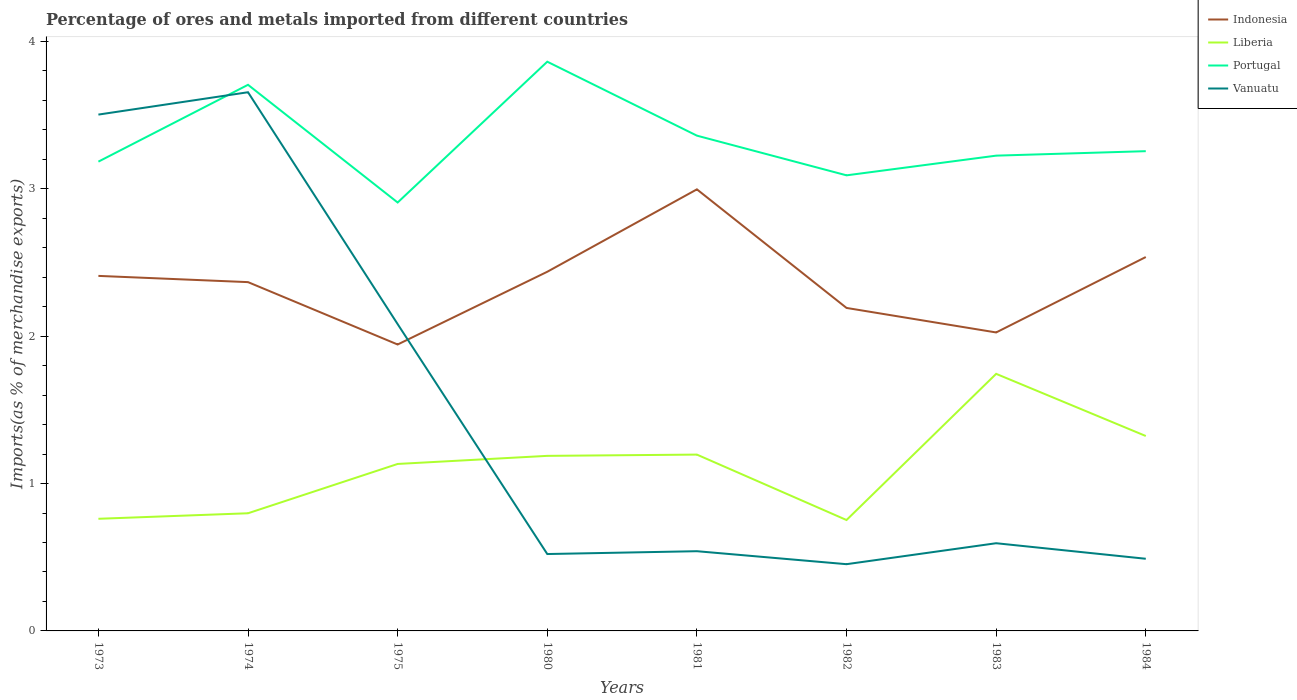How many different coloured lines are there?
Provide a short and direct response. 4. Is the number of lines equal to the number of legend labels?
Make the answer very short. Yes. Across all years, what is the maximum percentage of imports to different countries in Vanuatu?
Your answer should be compact. 0.45. What is the total percentage of imports to different countries in Indonesia in the graph?
Give a very brief answer. -0.08. What is the difference between the highest and the second highest percentage of imports to different countries in Vanuatu?
Make the answer very short. 3.2. What is the difference between the highest and the lowest percentage of imports to different countries in Liberia?
Your response must be concise. 5. Is the percentage of imports to different countries in Liberia strictly greater than the percentage of imports to different countries in Portugal over the years?
Ensure brevity in your answer.  Yes. How many years are there in the graph?
Offer a very short reply. 8. What is the difference between two consecutive major ticks on the Y-axis?
Make the answer very short. 1. Does the graph contain grids?
Your answer should be very brief. No. How are the legend labels stacked?
Your answer should be compact. Vertical. What is the title of the graph?
Your response must be concise. Percentage of ores and metals imported from different countries. What is the label or title of the X-axis?
Your answer should be very brief. Years. What is the label or title of the Y-axis?
Provide a succinct answer. Imports(as % of merchandise exports). What is the Imports(as % of merchandise exports) in Indonesia in 1973?
Provide a succinct answer. 2.41. What is the Imports(as % of merchandise exports) of Liberia in 1973?
Your answer should be compact. 0.76. What is the Imports(as % of merchandise exports) in Portugal in 1973?
Offer a terse response. 3.18. What is the Imports(as % of merchandise exports) of Vanuatu in 1973?
Offer a very short reply. 3.5. What is the Imports(as % of merchandise exports) of Indonesia in 1974?
Make the answer very short. 2.37. What is the Imports(as % of merchandise exports) of Liberia in 1974?
Provide a succinct answer. 0.8. What is the Imports(as % of merchandise exports) of Portugal in 1974?
Offer a terse response. 3.71. What is the Imports(as % of merchandise exports) in Vanuatu in 1974?
Provide a short and direct response. 3.66. What is the Imports(as % of merchandise exports) of Indonesia in 1975?
Your answer should be very brief. 1.94. What is the Imports(as % of merchandise exports) in Liberia in 1975?
Give a very brief answer. 1.13. What is the Imports(as % of merchandise exports) in Portugal in 1975?
Give a very brief answer. 2.91. What is the Imports(as % of merchandise exports) of Vanuatu in 1975?
Keep it short and to the point. 2.08. What is the Imports(as % of merchandise exports) in Indonesia in 1980?
Offer a very short reply. 2.44. What is the Imports(as % of merchandise exports) in Liberia in 1980?
Your answer should be compact. 1.19. What is the Imports(as % of merchandise exports) of Portugal in 1980?
Offer a very short reply. 3.86. What is the Imports(as % of merchandise exports) of Vanuatu in 1980?
Give a very brief answer. 0.52. What is the Imports(as % of merchandise exports) in Indonesia in 1981?
Your response must be concise. 3. What is the Imports(as % of merchandise exports) of Liberia in 1981?
Offer a very short reply. 1.2. What is the Imports(as % of merchandise exports) of Portugal in 1981?
Your answer should be compact. 3.36. What is the Imports(as % of merchandise exports) in Vanuatu in 1981?
Provide a succinct answer. 0.54. What is the Imports(as % of merchandise exports) of Indonesia in 1982?
Your response must be concise. 2.19. What is the Imports(as % of merchandise exports) in Liberia in 1982?
Your answer should be very brief. 0.75. What is the Imports(as % of merchandise exports) of Portugal in 1982?
Your answer should be very brief. 3.09. What is the Imports(as % of merchandise exports) in Vanuatu in 1982?
Ensure brevity in your answer.  0.45. What is the Imports(as % of merchandise exports) of Indonesia in 1983?
Make the answer very short. 2.03. What is the Imports(as % of merchandise exports) of Liberia in 1983?
Offer a very short reply. 1.74. What is the Imports(as % of merchandise exports) of Portugal in 1983?
Your response must be concise. 3.23. What is the Imports(as % of merchandise exports) of Vanuatu in 1983?
Ensure brevity in your answer.  0.6. What is the Imports(as % of merchandise exports) in Indonesia in 1984?
Ensure brevity in your answer.  2.54. What is the Imports(as % of merchandise exports) of Liberia in 1984?
Give a very brief answer. 1.32. What is the Imports(as % of merchandise exports) in Portugal in 1984?
Offer a terse response. 3.26. What is the Imports(as % of merchandise exports) of Vanuatu in 1984?
Your answer should be very brief. 0.49. Across all years, what is the maximum Imports(as % of merchandise exports) in Indonesia?
Keep it short and to the point. 3. Across all years, what is the maximum Imports(as % of merchandise exports) of Liberia?
Make the answer very short. 1.74. Across all years, what is the maximum Imports(as % of merchandise exports) of Portugal?
Give a very brief answer. 3.86. Across all years, what is the maximum Imports(as % of merchandise exports) of Vanuatu?
Keep it short and to the point. 3.66. Across all years, what is the minimum Imports(as % of merchandise exports) of Indonesia?
Your response must be concise. 1.94. Across all years, what is the minimum Imports(as % of merchandise exports) in Liberia?
Your response must be concise. 0.75. Across all years, what is the minimum Imports(as % of merchandise exports) of Portugal?
Your answer should be compact. 2.91. Across all years, what is the minimum Imports(as % of merchandise exports) in Vanuatu?
Make the answer very short. 0.45. What is the total Imports(as % of merchandise exports) in Indonesia in the graph?
Offer a terse response. 18.91. What is the total Imports(as % of merchandise exports) of Liberia in the graph?
Your answer should be compact. 8.9. What is the total Imports(as % of merchandise exports) of Portugal in the graph?
Provide a succinct answer. 26.6. What is the total Imports(as % of merchandise exports) in Vanuatu in the graph?
Your answer should be very brief. 11.84. What is the difference between the Imports(as % of merchandise exports) in Indonesia in 1973 and that in 1974?
Your response must be concise. 0.04. What is the difference between the Imports(as % of merchandise exports) in Liberia in 1973 and that in 1974?
Provide a short and direct response. -0.04. What is the difference between the Imports(as % of merchandise exports) of Portugal in 1973 and that in 1974?
Your answer should be compact. -0.52. What is the difference between the Imports(as % of merchandise exports) in Vanuatu in 1973 and that in 1974?
Your answer should be compact. -0.15. What is the difference between the Imports(as % of merchandise exports) in Indonesia in 1973 and that in 1975?
Offer a terse response. 0.47. What is the difference between the Imports(as % of merchandise exports) in Liberia in 1973 and that in 1975?
Your response must be concise. -0.37. What is the difference between the Imports(as % of merchandise exports) in Portugal in 1973 and that in 1975?
Your answer should be very brief. 0.28. What is the difference between the Imports(as % of merchandise exports) of Vanuatu in 1973 and that in 1975?
Offer a terse response. 1.42. What is the difference between the Imports(as % of merchandise exports) in Indonesia in 1973 and that in 1980?
Provide a short and direct response. -0.03. What is the difference between the Imports(as % of merchandise exports) of Liberia in 1973 and that in 1980?
Offer a terse response. -0.43. What is the difference between the Imports(as % of merchandise exports) in Portugal in 1973 and that in 1980?
Your answer should be very brief. -0.68. What is the difference between the Imports(as % of merchandise exports) of Vanuatu in 1973 and that in 1980?
Offer a very short reply. 2.98. What is the difference between the Imports(as % of merchandise exports) of Indonesia in 1973 and that in 1981?
Provide a succinct answer. -0.59. What is the difference between the Imports(as % of merchandise exports) of Liberia in 1973 and that in 1981?
Provide a succinct answer. -0.44. What is the difference between the Imports(as % of merchandise exports) of Portugal in 1973 and that in 1981?
Offer a very short reply. -0.18. What is the difference between the Imports(as % of merchandise exports) of Vanuatu in 1973 and that in 1981?
Offer a very short reply. 2.96. What is the difference between the Imports(as % of merchandise exports) of Indonesia in 1973 and that in 1982?
Your answer should be compact. 0.22. What is the difference between the Imports(as % of merchandise exports) of Liberia in 1973 and that in 1982?
Your response must be concise. 0.01. What is the difference between the Imports(as % of merchandise exports) in Portugal in 1973 and that in 1982?
Provide a succinct answer. 0.09. What is the difference between the Imports(as % of merchandise exports) of Vanuatu in 1973 and that in 1982?
Your answer should be compact. 3.05. What is the difference between the Imports(as % of merchandise exports) in Indonesia in 1973 and that in 1983?
Your answer should be very brief. 0.38. What is the difference between the Imports(as % of merchandise exports) in Liberia in 1973 and that in 1983?
Give a very brief answer. -0.98. What is the difference between the Imports(as % of merchandise exports) of Portugal in 1973 and that in 1983?
Ensure brevity in your answer.  -0.04. What is the difference between the Imports(as % of merchandise exports) in Vanuatu in 1973 and that in 1983?
Make the answer very short. 2.91. What is the difference between the Imports(as % of merchandise exports) in Indonesia in 1973 and that in 1984?
Provide a succinct answer. -0.13. What is the difference between the Imports(as % of merchandise exports) of Liberia in 1973 and that in 1984?
Give a very brief answer. -0.56. What is the difference between the Imports(as % of merchandise exports) in Portugal in 1973 and that in 1984?
Your answer should be very brief. -0.07. What is the difference between the Imports(as % of merchandise exports) in Vanuatu in 1973 and that in 1984?
Your answer should be very brief. 3.01. What is the difference between the Imports(as % of merchandise exports) in Indonesia in 1974 and that in 1975?
Your answer should be compact. 0.42. What is the difference between the Imports(as % of merchandise exports) of Liberia in 1974 and that in 1975?
Offer a very short reply. -0.33. What is the difference between the Imports(as % of merchandise exports) of Portugal in 1974 and that in 1975?
Your answer should be very brief. 0.8. What is the difference between the Imports(as % of merchandise exports) in Vanuatu in 1974 and that in 1975?
Provide a short and direct response. 1.57. What is the difference between the Imports(as % of merchandise exports) of Indonesia in 1974 and that in 1980?
Provide a succinct answer. -0.07. What is the difference between the Imports(as % of merchandise exports) of Liberia in 1974 and that in 1980?
Make the answer very short. -0.39. What is the difference between the Imports(as % of merchandise exports) of Portugal in 1974 and that in 1980?
Your answer should be very brief. -0.16. What is the difference between the Imports(as % of merchandise exports) in Vanuatu in 1974 and that in 1980?
Keep it short and to the point. 3.13. What is the difference between the Imports(as % of merchandise exports) of Indonesia in 1974 and that in 1981?
Provide a short and direct response. -0.63. What is the difference between the Imports(as % of merchandise exports) of Liberia in 1974 and that in 1981?
Your answer should be compact. -0.4. What is the difference between the Imports(as % of merchandise exports) in Portugal in 1974 and that in 1981?
Offer a terse response. 0.34. What is the difference between the Imports(as % of merchandise exports) of Vanuatu in 1974 and that in 1981?
Keep it short and to the point. 3.11. What is the difference between the Imports(as % of merchandise exports) in Indonesia in 1974 and that in 1982?
Ensure brevity in your answer.  0.18. What is the difference between the Imports(as % of merchandise exports) of Liberia in 1974 and that in 1982?
Provide a short and direct response. 0.05. What is the difference between the Imports(as % of merchandise exports) in Portugal in 1974 and that in 1982?
Provide a succinct answer. 0.61. What is the difference between the Imports(as % of merchandise exports) of Vanuatu in 1974 and that in 1982?
Make the answer very short. 3.2. What is the difference between the Imports(as % of merchandise exports) of Indonesia in 1974 and that in 1983?
Your answer should be compact. 0.34. What is the difference between the Imports(as % of merchandise exports) in Liberia in 1974 and that in 1983?
Offer a very short reply. -0.95. What is the difference between the Imports(as % of merchandise exports) in Portugal in 1974 and that in 1983?
Give a very brief answer. 0.48. What is the difference between the Imports(as % of merchandise exports) in Vanuatu in 1974 and that in 1983?
Offer a very short reply. 3.06. What is the difference between the Imports(as % of merchandise exports) in Indonesia in 1974 and that in 1984?
Make the answer very short. -0.17. What is the difference between the Imports(as % of merchandise exports) in Liberia in 1974 and that in 1984?
Provide a short and direct response. -0.52. What is the difference between the Imports(as % of merchandise exports) of Portugal in 1974 and that in 1984?
Give a very brief answer. 0.45. What is the difference between the Imports(as % of merchandise exports) in Vanuatu in 1974 and that in 1984?
Your response must be concise. 3.17. What is the difference between the Imports(as % of merchandise exports) in Indonesia in 1975 and that in 1980?
Your answer should be compact. -0.49. What is the difference between the Imports(as % of merchandise exports) of Liberia in 1975 and that in 1980?
Your answer should be very brief. -0.05. What is the difference between the Imports(as % of merchandise exports) in Portugal in 1975 and that in 1980?
Provide a short and direct response. -0.96. What is the difference between the Imports(as % of merchandise exports) of Vanuatu in 1975 and that in 1980?
Keep it short and to the point. 1.56. What is the difference between the Imports(as % of merchandise exports) of Indonesia in 1975 and that in 1981?
Your answer should be compact. -1.05. What is the difference between the Imports(as % of merchandise exports) of Liberia in 1975 and that in 1981?
Keep it short and to the point. -0.06. What is the difference between the Imports(as % of merchandise exports) of Portugal in 1975 and that in 1981?
Provide a short and direct response. -0.45. What is the difference between the Imports(as % of merchandise exports) of Vanuatu in 1975 and that in 1981?
Keep it short and to the point. 1.54. What is the difference between the Imports(as % of merchandise exports) of Indonesia in 1975 and that in 1982?
Provide a short and direct response. -0.25. What is the difference between the Imports(as % of merchandise exports) of Liberia in 1975 and that in 1982?
Give a very brief answer. 0.38. What is the difference between the Imports(as % of merchandise exports) of Portugal in 1975 and that in 1982?
Make the answer very short. -0.18. What is the difference between the Imports(as % of merchandise exports) of Vanuatu in 1975 and that in 1982?
Provide a succinct answer. 1.63. What is the difference between the Imports(as % of merchandise exports) in Indonesia in 1975 and that in 1983?
Provide a short and direct response. -0.08. What is the difference between the Imports(as % of merchandise exports) in Liberia in 1975 and that in 1983?
Provide a short and direct response. -0.61. What is the difference between the Imports(as % of merchandise exports) in Portugal in 1975 and that in 1983?
Keep it short and to the point. -0.32. What is the difference between the Imports(as % of merchandise exports) in Vanuatu in 1975 and that in 1983?
Your answer should be very brief. 1.49. What is the difference between the Imports(as % of merchandise exports) in Indonesia in 1975 and that in 1984?
Your answer should be very brief. -0.59. What is the difference between the Imports(as % of merchandise exports) in Liberia in 1975 and that in 1984?
Make the answer very short. -0.19. What is the difference between the Imports(as % of merchandise exports) in Portugal in 1975 and that in 1984?
Provide a short and direct response. -0.35. What is the difference between the Imports(as % of merchandise exports) of Vanuatu in 1975 and that in 1984?
Your answer should be compact. 1.59. What is the difference between the Imports(as % of merchandise exports) in Indonesia in 1980 and that in 1981?
Make the answer very short. -0.56. What is the difference between the Imports(as % of merchandise exports) of Liberia in 1980 and that in 1981?
Your answer should be very brief. -0.01. What is the difference between the Imports(as % of merchandise exports) in Portugal in 1980 and that in 1981?
Provide a succinct answer. 0.5. What is the difference between the Imports(as % of merchandise exports) in Vanuatu in 1980 and that in 1981?
Your answer should be compact. -0.02. What is the difference between the Imports(as % of merchandise exports) in Indonesia in 1980 and that in 1982?
Provide a short and direct response. 0.25. What is the difference between the Imports(as % of merchandise exports) of Liberia in 1980 and that in 1982?
Provide a short and direct response. 0.44. What is the difference between the Imports(as % of merchandise exports) in Portugal in 1980 and that in 1982?
Your answer should be very brief. 0.77. What is the difference between the Imports(as % of merchandise exports) in Vanuatu in 1980 and that in 1982?
Provide a short and direct response. 0.07. What is the difference between the Imports(as % of merchandise exports) of Indonesia in 1980 and that in 1983?
Your response must be concise. 0.41. What is the difference between the Imports(as % of merchandise exports) in Liberia in 1980 and that in 1983?
Your answer should be compact. -0.56. What is the difference between the Imports(as % of merchandise exports) of Portugal in 1980 and that in 1983?
Your answer should be very brief. 0.64. What is the difference between the Imports(as % of merchandise exports) in Vanuatu in 1980 and that in 1983?
Your answer should be compact. -0.07. What is the difference between the Imports(as % of merchandise exports) of Indonesia in 1980 and that in 1984?
Ensure brevity in your answer.  -0.1. What is the difference between the Imports(as % of merchandise exports) in Liberia in 1980 and that in 1984?
Ensure brevity in your answer.  -0.13. What is the difference between the Imports(as % of merchandise exports) in Portugal in 1980 and that in 1984?
Ensure brevity in your answer.  0.61. What is the difference between the Imports(as % of merchandise exports) in Vanuatu in 1980 and that in 1984?
Your answer should be very brief. 0.03. What is the difference between the Imports(as % of merchandise exports) in Indonesia in 1981 and that in 1982?
Offer a very short reply. 0.8. What is the difference between the Imports(as % of merchandise exports) in Liberia in 1981 and that in 1982?
Your answer should be very brief. 0.44. What is the difference between the Imports(as % of merchandise exports) in Portugal in 1981 and that in 1982?
Offer a terse response. 0.27. What is the difference between the Imports(as % of merchandise exports) in Vanuatu in 1981 and that in 1982?
Provide a short and direct response. 0.09. What is the difference between the Imports(as % of merchandise exports) in Indonesia in 1981 and that in 1983?
Your answer should be compact. 0.97. What is the difference between the Imports(as % of merchandise exports) in Liberia in 1981 and that in 1983?
Ensure brevity in your answer.  -0.55. What is the difference between the Imports(as % of merchandise exports) of Portugal in 1981 and that in 1983?
Give a very brief answer. 0.14. What is the difference between the Imports(as % of merchandise exports) of Vanuatu in 1981 and that in 1983?
Offer a very short reply. -0.05. What is the difference between the Imports(as % of merchandise exports) in Indonesia in 1981 and that in 1984?
Offer a terse response. 0.46. What is the difference between the Imports(as % of merchandise exports) of Liberia in 1981 and that in 1984?
Provide a short and direct response. -0.13. What is the difference between the Imports(as % of merchandise exports) in Portugal in 1981 and that in 1984?
Your response must be concise. 0.11. What is the difference between the Imports(as % of merchandise exports) of Vanuatu in 1981 and that in 1984?
Make the answer very short. 0.05. What is the difference between the Imports(as % of merchandise exports) in Indonesia in 1982 and that in 1983?
Ensure brevity in your answer.  0.17. What is the difference between the Imports(as % of merchandise exports) in Liberia in 1982 and that in 1983?
Offer a very short reply. -0.99. What is the difference between the Imports(as % of merchandise exports) in Portugal in 1982 and that in 1983?
Give a very brief answer. -0.13. What is the difference between the Imports(as % of merchandise exports) of Vanuatu in 1982 and that in 1983?
Keep it short and to the point. -0.14. What is the difference between the Imports(as % of merchandise exports) in Indonesia in 1982 and that in 1984?
Ensure brevity in your answer.  -0.35. What is the difference between the Imports(as % of merchandise exports) of Liberia in 1982 and that in 1984?
Give a very brief answer. -0.57. What is the difference between the Imports(as % of merchandise exports) of Portugal in 1982 and that in 1984?
Offer a very short reply. -0.16. What is the difference between the Imports(as % of merchandise exports) of Vanuatu in 1982 and that in 1984?
Give a very brief answer. -0.04. What is the difference between the Imports(as % of merchandise exports) of Indonesia in 1983 and that in 1984?
Keep it short and to the point. -0.51. What is the difference between the Imports(as % of merchandise exports) of Liberia in 1983 and that in 1984?
Your answer should be compact. 0.42. What is the difference between the Imports(as % of merchandise exports) of Portugal in 1983 and that in 1984?
Your answer should be very brief. -0.03. What is the difference between the Imports(as % of merchandise exports) of Vanuatu in 1983 and that in 1984?
Your response must be concise. 0.11. What is the difference between the Imports(as % of merchandise exports) of Indonesia in 1973 and the Imports(as % of merchandise exports) of Liberia in 1974?
Your answer should be compact. 1.61. What is the difference between the Imports(as % of merchandise exports) in Indonesia in 1973 and the Imports(as % of merchandise exports) in Portugal in 1974?
Offer a terse response. -1.3. What is the difference between the Imports(as % of merchandise exports) of Indonesia in 1973 and the Imports(as % of merchandise exports) of Vanuatu in 1974?
Provide a short and direct response. -1.25. What is the difference between the Imports(as % of merchandise exports) of Liberia in 1973 and the Imports(as % of merchandise exports) of Portugal in 1974?
Your response must be concise. -2.95. What is the difference between the Imports(as % of merchandise exports) in Liberia in 1973 and the Imports(as % of merchandise exports) in Vanuatu in 1974?
Your answer should be compact. -2.89. What is the difference between the Imports(as % of merchandise exports) of Portugal in 1973 and the Imports(as % of merchandise exports) of Vanuatu in 1974?
Offer a terse response. -0.47. What is the difference between the Imports(as % of merchandise exports) in Indonesia in 1973 and the Imports(as % of merchandise exports) in Liberia in 1975?
Keep it short and to the point. 1.28. What is the difference between the Imports(as % of merchandise exports) of Indonesia in 1973 and the Imports(as % of merchandise exports) of Portugal in 1975?
Keep it short and to the point. -0.5. What is the difference between the Imports(as % of merchandise exports) of Indonesia in 1973 and the Imports(as % of merchandise exports) of Vanuatu in 1975?
Your response must be concise. 0.33. What is the difference between the Imports(as % of merchandise exports) of Liberia in 1973 and the Imports(as % of merchandise exports) of Portugal in 1975?
Offer a terse response. -2.15. What is the difference between the Imports(as % of merchandise exports) in Liberia in 1973 and the Imports(as % of merchandise exports) in Vanuatu in 1975?
Ensure brevity in your answer.  -1.32. What is the difference between the Imports(as % of merchandise exports) in Portugal in 1973 and the Imports(as % of merchandise exports) in Vanuatu in 1975?
Give a very brief answer. 1.1. What is the difference between the Imports(as % of merchandise exports) in Indonesia in 1973 and the Imports(as % of merchandise exports) in Liberia in 1980?
Your answer should be very brief. 1.22. What is the difference between the Imports(as % of merchandise exports) of Indonesia in 1973 and the Imports(as % of merchandise exports) of Portugal in 1980?
Ensure brevity in your answer.  -1.45. What is the difference between the Imports(as % of merchandise exports) of Indonesia in 1973 and the Imports(as % of merchandise exports) of Vanuatu in 1980?
Your response must be concise. 1.89. What is the difference between the Imports(as % of merchandise exports) of Liberia in 1973 and the Imports(as % of merchandise exports) of Portugal in 1980?
Ensure brevity in your answer.  -3.1. What is the difference between the Imports(as % of merchandise exports) of Liberia in 1973 and the Imports(as % of merchandise exports) of Vanuatu in 1980?
Make the answer very short. 0.24. What is the difference between the Imports(as % of merchandise exports) of Portugal in 1973 and the Imports(as % of merchandise exports) of Vanuatu in 1980?
Provide a succinct answer. 2.66. What is the difference between the Imports(as % of merchandise exports) of Indonesia in 1973 and the Imports(as % of merchandise exports) of Liberia in 1981?
Ensure brevity in your answer.  1.21. What is the difference between the Imports(as % of merchandise exports) in Indonesia in 1973 and the Imports(as % of merchandise exports) in Portugal in 1981?
Your answer should be very brief. -0.95. What is the difference between the Imports(as % of merchandise exports) of Indonesia in 1973 and the Imports(as % of merchandise exports) of Vanuatu in 1981?
Your response must be concise. 1.87. What is the difference between the Imports(as % of merchandise exports) of Liberia in 1973 and the Imports(as % of merchandise exports) of Portugal in 1981?
Make the answer very short. -2.6. What is the difference between the Imports(as % of merchandise exports) of Liberia in 1973 and the Imports(as % of merchandise exports) of Vanuatu in 1981?
Offer a very short reply. 0.22. What is the difference between the Imports(as % of merchandise exports) of Portugal in 1973 and the Imports(as % of merchandise exports) of Vanuatu in 1981?
Offer a very short reply. 2.64. What is the difference between the Imports(as % of merchandise exports) in Indonesia in 1973 and the Imports(as % of merchandise exports) in Liberia in 1982?
Keep it short and to the point. 1.66. What is the difference between the Imports(as % of merchandise exports) of Indonesia in 1973 and the Imports(as % of merchandise exports) of Portugal in 1982?
Your answer should be very brief. -0.68. What is the difference between the Imports(as % of merchandise exports) of Indonesia in 1973 and the Imports(as % of merchandise exports) of Vanuatu in 1982?
Make the answer very short. 1.96. What is the difference between the Imports(as % of merchandise exports) of Liberia in 1973 and the Imports(as % of merchandise exports) of Portugal in 1982?
Your answer should be compact. -2.33. What is the difference between the Imports(as % of merchandise exports) in Liberia in 1973 and the Imports(as % of merchandise exports) in Vanuatu in 1982?
Keep it short and to the point. 0.31. What is the difference between the Imports(as % of merchandise exports) of Portugal in 1973 and the Imports(as % of merchandise exports) of Vanuatu in 1982?
Your answer should be very brief. 2.73. What is the difference between the Imports(as % of merchandise exports) of Indonesia in 1973 and the Imports(as % of merchandise exports) of Liberia in 1983?
Keep it short and to the point. 0.66. What is the difference between the Imports(as % of merchandise exports) in Indonesia in 1973 and the Imports(as % of merchandise exports) in Portugal in 1983?
Make the answer very short. -0.82. What is the difference between the Imports(as % of merchandise exports) of Indonesia in 1973 and the Imports(as % of merchandise exports) of Vanuatu in 1983?
Provide a short and direct response. 1.81. What is the difference between the Imports(as % of merchandise exports) in Liberia in 1973 and the Imports(as % of merchandise exports) in Portugal in 1983?
Offer a terse response. -2.46. What is the difference between the Imports(as % of merchandise exports) in Liberia in 1973 and the Imports(as % of merchandise exports) in Vanuatu in 1983?
Make the answer very short. 0.17. What is the difference between the Imports(as % of merchandise exports) in Portugal in 1973 and the Imports(as % of merchandise exports) in Vanuatu in 1983?
Offer a terse response. 2.59. What is the difference between the Imports(as % of merchandise exports) in Indonesia in 1973 and the Imports(as % of merchandise exports) in Liberia in 1984?
Provide a short and direct response. 1.09. What is the difference between the Imports(as % of merchandise exports) of Indonesia in 1973 and the Imports(as % of merchandise exports) of Portugal in 1984?
Provide a short and direct response. -0.85. What is the difference between the Imports(as % of merchandise exports) in Indonesia in 1973 and the Imports(as % of merchandise exports) in Vanuatu in 1984?
Keep it short and to the point. 1.92. What is the difference between the Imports(as % of merchandise exports) of Liberia in 1973 and the Imports(as % of merchandise exports) of Portugal in 1984?
Your answer should be very brief. -2.49. What is the difference between the Imports(as % of merchandise exports) in Liberia in 1973 and the Imports(as % of merchandise exports) in Vanuatu in 1984?
Ensure brevity in your answer.  0.27. What is the difference between the Imports(as % of merchandise exports) in Portugal in 1973 and the Imports(as % of merchandise exports) in Vanuatu in 1984?
Keep it short and to the point. 2.7. What is the difference between the Imports(as % of merchandise exports) of Indonesia in 1974 and the Imports(as % of merchandise exports) of Liberia in 1975?
Make the answer very short. 1.23. What is the difference between the Imports(as % of merchandise exports) of Indonesia in 1974 and the Imports(as % of merchandise exports) of Portugal in 1975?
Make the answer very short. -0.54. What is the difference between the Imports(as % of merchandise exports) of Indonesia in 1974 and the Imports(as % of merchandise exports) of Vanuatu in 1975?
Offer a terse response. 0.28. What is the difference between the Imports(as % of merchandise exports) in Liberia in 1974 and the Imports(as % of merchandise exports) in Portugal in 1975?
Ensure brevity in your answer.  -2.11. What is the difference between the Imports(as % of merchandise exports) in Liberia in 1974 and the Imports(as % of merchandise exports) in Vanuatu in 1975?
Give a very brief answer. -1.28. What is the difference between the Imports(as % of merchandise exports) of Portugal in 1974 and the Imports(as % of merchandise exports) of Vanuatu in 1975?
Offer a very short reply. 1.62. What is the difference between the Imports(as % of merchandise exports) of Indonesia in 1974 and the Imports(as % of merchandise exports) of Liberia in 1980?
Ensure brevity in your answer.  1.18. What is the difference between the Imports(as % of merchandise exports) of Indonesia in 1974 and the Imports(as % of merchandise exports) of Portugal in 1980?
Provide a short and direct response. -1.5. What is the difference between the Imports(as % of merchandise exports) in Indonesia in 1974 and the Imports(as % of merchandise exports) in Vanuatu in 1980?
Make the answer very short. 1.85. What is the difference between the Imports(as % of merchandise exports) in Liberia in 1974 and the Imports(as % of merchandise exports) in Portugal in 1980?
Provide a succinct answer. -3.06. What is the difference between the Imports(as % of merchandise exports) in Liberia in 1974 and the Imports(as % of merchandise exports) in Vanuatu in 1980?
Make the answer very short. 0.28. What is the difference between the Imports(as % of merchandise exports) of Portugal in 1974 and the Imports(as % of merchandise exports) of Vanuatu in 1980?
Provide a succinct answer. 3.18. What is the difference between the Imports(as % of merchandise exports) of Indonesia in 1974 and the Imports(as % of merchandise exports) of Liberia in 1981?
Offer a terse response. 1.17. What is the difference between the Imports(as % of merchandise exports) of Indonesia in 1974 and the Imports(as % of merchandise exports) of Portugal in 1981?
Provide a succinct answer. -0.99. What is the difference between the Imports(as % of merchandise exports) in Indonesia in 1974 and the Imports(as % of merchandise exports) in Vanuatu in 1981?
Provide a short and direct response. 1.83. What is the difference between the Imports(as % of merchandise exports) in Liberia in 1974 and the Imports(as % of merchandise exports) in Portugal in 1981?
Offer a terse response. -2.56. What is the difference between the Imports(as % of merchandise exports) in Liberia in 1974 and the Imports(as % of merchandise exports) in Vanuatu in 1981?
Provide a short and direct response. 0.26. What is the difference between the Imports(as % of merchandise exports) of Portugal in 1974 and the Imports(as % of merchandise exports) of Vanuatu in 1981?
Make the answer very short. 3.17. What is the difference between the Imports(as % of merchandise exports) of Indonesia in 1974 and the Imports(as % of merchandise exports) of Liberia in 1982?
Keep it short and to the point. 1.61. What is the difference between the Imports(as % of merchandise exports) in Indonesia in 1974 and the Imports(as % of merchandise exports) in Portugal in 1982?
Make the answer very short. -0.72. What is the difference between the Imports(as % of merchandise exports) in Indonesia in 1974 and the Imports(as % of merchandise exports) in Vanuatu in 1982?
Your response must be concise. 1.91. What is the difference between the Imports(as % of merchandise exports) of Liberia in 1974 and the Imports(as % of merchandise exports) of Portugal in 1982?
Provide a succinct answer. -2.29. What is the difference between the Imports(as % of merchandise exports) of Liberia in 1974 and the Imports(as % of merchandise exports) of Vanuatu in 1982?
Ensure brevity in your answer.  0.35. What is the difference between the Imports(as % of merchandise exports) in Portugal in 1974 and the Imports(as % of merchandise exports) in Vanuatu in 1982?
Your response must be concise. 3.25. What is the difference between the Imports(as % of merchandise exports) of Indonesia in 1974 and the Imports(as % of merchandise exports) of Liberia in 1983?
Your answer should be very brief. 0.62. What is the difference between the Imports(as % of merchandise exports) of Indonesia in 1974 and the Imports(as % of merchandise exports) of Portugal in 1983?
Make the answer very short. -0.86. What is the difference between the Imports(as % of merchandise exports) in Indonesia in 1974 and the Imports(as % of merchandise exports) in Vanuatu in 1983?
Give a very brief answer. 1.77. What is the difference between the Imports(as % of merchandise exports) of Liberia in 1974 and the Imports(as % of merchandise exports) of Portugal in 1983?
Your response must be concise. -2.43. What is the difference between the Imports(as % of merchandise exports) of Liberia in 1974 and the Imports(as % of merchandise exports) of Vanuatu in 1983?
Ensure brevity in your answer.  0.2. What is the difference between the Imports(as % of merchandise exports) of Portugal in 1974 and the Imports(as % of merchandise exports) of Vanuatu in 1983?
Your response must be concise. 3.11. What is the difference between the Imports(as % of merchandise exports) of Indonesia in 1974 and the Imports(as % of merchandise exports) of Liberia in 1984?
Provide a short and direct response. 1.04. What is the difference between the Imports(as % of merchandise exports) in Indonesia in 1974 and the Imports(as % of merchandise exports) in Portugal in 1984?
Offer a very short reply. -0.89. What is the difference between the Imports(as % of merchandise exports) in Indonesia in 1974 and the Imports(as % of merchandise exports) in Vanuatu in 1984?
Your answer should be compact. 1.88. What is the difference between the Imports(as % of merchandise exports) in Liberia in 1974 and the Imports(as % of merchandise exports) in Portugal in 1984?
Make the answer very short. -2.46. What is the difference between the Imports(as % of merchandise exports) of Liberia in 1974 and the Imports(as % of merchandise exports) of Vanuatu in 1984?
Provide a short and direct response. 0.31. What is the difference between the Imports(as % of merchandise exports) of Portugal in 1974 and the Imports(as % of merchandise exports) of Vanuatu in 1984?
Provide a short and direct response. 3.22. What is the difference between the Imports(as % of merchandise exports) in Indonesia in 1975 and the Imports(as % of merchandise exports) in Liberia in 1980?
Provide a short and direct response. 0.76. What is the difference between the Imports(as % of merchandise exports) in Indonesia in 1975 and the Imports(as % of merchandise exports) in Portugal in 1980?
Offer a terse response. -1.92. What is the difference between the Imports(as % of merchandise exports) in Indonesia in 1975 and the Imports(as % of merchandise exports) in Vanuatu in 1980?
Offer a terse response. 1.42. What is the difference between the Imports(as % of merchandise exports) in Liberia in 1975 and the Imports(as % of merchandise exports) in Portugal in 1980?
Provide a short and direct response. -2.73. What is the difference between the Imports(as % of merchandise exports) of Liberia in 1975 and the Imports(as % of merchandise exports) of Vanuatu in 1980?
Offer a terse response. 0.61. What is the difference between the Imports(as % of merchandise exports) in Portugal in 1975 and the Imports(as % of merchandise exports) in Vanuatu in 1980?
Keep it short and to the point. 2.39. What is the difference between the Imports(as % of merchandise exports) of Indonesia in 1975 and the Imports(as % of merchandise exports) of Liberia in 1981?
Give a very brief answer. 0.75. What is the difference between the Imports(as % of merchandise exports) of Indonesia in 1975 and the Imports(as % of merchandise exports) of Portugal in 1981?
Give a very brief answer. -1.42. What is the difference between the Imports(as % of merchandise exports) of Indonesia in 1975 and the Imports(as % of merchandise exports) of Vanuatu in 1981?
Offer a very short reply. 1.4. What is the difference between the Imports(as % of merchandise exports) of Liberia in 1975 and the Imports(as % of merchandise exports) of Portugal in 1981?
Give a very brief answer. -2.23. What is the difference between the Imports(as % of merchandise exports) of Liberia in 1975 and the Imports(as % of merchandise exports) of Vanuatu in 1981?
Offer a very short reply. 0.59. What is the difference between the Imports(as % of merchandise exports) in Portugal in 1975 and the Imports(as % of merchandise exports) in Vanuatu in 1981?
Your response must be concise. 2.37. What is the difference between the Imports(as % of merchandise exports) of Indonesia in 1975 and the Imports(as % of merchandise exports) of Liberia in 1982?
Provide a short and direct response. 1.19. What is the difference between the Imports(as % of merchandise exports) in Indonesia in 1975 and the Imports(as % of merchandise exports) in Portugal in 1982?
Your answer should be very brief. -1.15. What is the difference between the Imports(as % of merchandise exports) of Indonesia in 1975 and the Imports(as % of merchandise exports) of Vanuatu in 1982?
Keep it short and to the point. 1.49. What is the difference between the Imports(as % of merchandise exports) in Liberia in 1975 and the Imports(as % of merchandise exports) in Portugal in 1982?
Make the answer very short. -1.96. What is the difference between the Imports(as % of merchandise exports) in Liberia in 1975 and the Imports(as % of merchandise exports) in Vanuatu in 1982?
Your answer should be very brief. 0.68. What is the difference between the Imports(as % of merchandise exports) of Portugal in 1975 and the Imports(as % of merchandise exports) of Vanuatu in 1982?
Your answer should be compact. 2.45. What is the difference between the Imports(as % of merchandise exports) in Indonesia in 1975 and the Imports(as % of merchandise exports) in Liberia in 1983?
Keep it short and to the point. 0.2. What is the difference between the Imports(as % of merchandise exports) in Indonesia in 1975 and the Imports(as % of merchandise exports) in Portugal in 1983?
Your answer should be very brief. -1.28. What is the difference between the Imports(as % of merchandise exports) in Indonesia in 1975 and the Imports(as % of merchandise exports) in Vanuatu in 1983?
Offer a terse response. 1.35. What is the difference between the Imports(as % of merchandise exports) in Liberia in 1975 and the Imports(as % of merchandise exports) in Portugal in 1983?
Your response must be concise. -2.09. What is the difference between the Imports(as % of merchandise exports) in Liberia in 1975 and the Imports(as % of merchandise exports) in Vanuatu in 1983?
Provide a succinct answer. 0.54. What is the difference between the Imports(as % of merchandise exports) in Portugal in 1975 and the Imports(as % of merchandise exports) in Vanuatu in 1983?
Ensure brevity in your answer.  2.31. What is the difference between the Imports(as % of merchandise exports) of Indonesia in 1975 and the Imports(as % of merchandise exports) of Liberia in 1984?
Ensure brevity in your answer.  0.62. What is the difference between the Imports(as % of merchandise exports) in Indonesia in 1975 and the Imports(as % of merchandise exports) in Portugal in 1984?
Keep it short and to the point. -1.31. What is the difference between the Imports(as % of merchandise exports) of Indonesia in 1975 and the Imports(as % of merchandise exports) of Vanuatu in 1984?
Offer a terse response. 1.45. What is the difference between the Imports(as % of merchandise exports) of Liberia in 1975 and the Imports(as % of merchandise exports) of Portugal in 1984?
Your answer should be very brief. -2.12. What is the difference between the Imports(as % of merchandise exports) in Liberia in 1975 and the Imports(as % of merchandise exports) in Vanuatu in 1984?
Ensure brevity in your answer.  0.64. What is the difference between the Imports(as % of merchandise exports) of Portugal in 1975 and the Imports(as % of merchandise exports) of Vanuatu in 1984?
Give a very brief answer. 2.42. What is the difference between the Imports(as % of merchandise exports) of Indonesia in 1980 and the Imports(as % of merchandise exports) of Liberia in 1981?
Offer a terse response. 1.24. What is the difference between the Imports(as % of merchandise exports) in Indonesia in 1980 and the Imports(as % of merchandise exports) in Portugal in 1981?
Provide a short and direct response. -0.92. What is the difference between the Imports(as % of merchandise exports) of Indonesia in 1980 and the Imports(as % of merchandise exports) of Vanuatu in 1981?
Keep it short and to the point. 1.9. What is the difference between the Imports(as % of merchandise exports) in Liberia in 1980 and the Imports(as % of merchandise exports) in Portugal in 1981?
Keep it short and to the point. -2.17. What is the difference between the Imports(as % of merchandise exports) in Liberia in 1980 and the Imports(as % of merchandise exports) in Vanuatu in 1981?
Provide a succinct answer. 0.65. What is the difference between the Imports(as % of merchandise exports) in Portugal in 1980 and the Imports(as % of merchandise exports) in Vanuatu in 1981?
Keep it short and to the point. 3.32. What is the difference between the Imports(as % of merchandise exports) of Indonesia in 1980 and the Imports(as % of merchandise exports) of Liberia in 1982?
Make the answer very short. 1.68. What is the difference between the Imports(as % of merchandise exports) of Indonesia in 1980 and the Imports(as % of merchandise exports) of Portugal in 1982?
Your answer should be very brief. -0.65. What is the difference between the Imports(as % of merchandise exports) of Indonesia in 1980 and the Imports(as % of merchandise exports) of Vanuatu in 1982?
Offer a very short reply. 1.98. What is the difference between the Imports(as % of merchandise exports) of Liberia in 1980 and the Imports(as % of merchandise exports) of Portugal in 1982?
Offer a very short reply. -1.9. What is the difference between the Imports(as % of merchandise exports) in Liberia in 1980 and the Imports(as % of merchandise exports) in Vanuatu in 1982?
Provide a succinct answer. 0.74. What is the difference between the Imports(as % of merchandise exports) of Portugal in 1980 and the Imports(as % of merchandise exports) of Vanuatu in 1982?
Your answer should be very brief. 3.41. What is the difference between the Imports(as % of merchandise exports) of Indonesia in 1980 and the Imports(as % of merchandise exports) of Liberia in 1983?
Your answer should be very brief. 0.69. What is the difference between the Imports(as % of merchandise exports) in Indonesia in 1980 and the Imports(as % of merchandise exports) in Portugal in 1983?
Make the answer very short. -0.79. What is the difference between the Imports(as % of merchandise exports) in Indonesia in 1980 and the Imports(as % of merchandise exports) in Vanuatu in 1983?
Ensure brevity in your answer.  1.84. What is the difference between the Imports(as % of merchandise exports) in Liberia in 1980 and the Imports(as % of merchandise exports) in Portugal in 1983?
Give a very brief answer. -2.04. What is the difference between the Imports(as % of merchandise exports) of Liberia in 1980 and the Imports(as % of merchandise exports) of Vanuatu in 1983?
Your answer should be compact. 0.59. What is the difference between the Imports(as % of merchandise exports) in Portugal in 1980 and the Imports(as % of merchandise exports) in Vanuatu in 1983?
Ensure brevity in your answer.  3.27. What is the difference between the Imports(as % of merchandise exports) in Indonesia in 1980 and the Imports(as % of merchandise exports) in Liberia in 1984?
Your answer should be very brief. 1.11. What is the difference between the Imports(as % of merchandise exports) of Indonesia in 1980 and the Imports(as % of merchandise exports) of Portugal in 1984?
Your response must be concise. -0.82. What is the difference between the Imports(as % of merchandise exports) in Indonesia in 1980 and the Imports(as % of merchandise exports) in Vanuatu in 1984?
Your response must be concise. 1.95. What is the difference between the Imports(as % of merchandise exports) in Liberia in 1980 and the Imports(as % of merchandise exports) in Portugal in 1984?
Offer a very short reply. -2.07. What is the difference between the Imports(as % of merchandise exports) in Liberia in 1980 and the Imports(as % of merchandise exports) in Vanuatu in 1984?
Your answer should be very brief. 0.7. What is the difference between the Imports(as % of merchandise exports) of Portugal in 1980 and the Imports(as % of merchandise exports) of Vanuatu in 1984?
Keep it short and to the point. 3.37. What is the difference between the Imports(as % of merchandise exports) of Indonesia in 1981 and the Imports(as % of merchandise exports) of Liberia in 1982?
Offer a terse response. 2.24. What is the difference between the Imports(as % of merchandise exports) in Indonesia in 1981 and the Imports(as % of merchandise exports) in Portugal in 1982?
Your answer should be compact. -0.1. What is the difference between the Imports(as % of merchandise exports) of Indonesia in 1981 and the Imports(as % of merchandise exports) of Vanuatu in 1982?
Offer a terse response. 2.54. What is the difference between the Imports(as % of merchandise exports) of Liberia in 1981 and the Imports(as % of merchandise exports) of Portugal in 1982?
Provide a short and direct response. -1.9. What is the difference between the Imports(as % of merchandise exports) of Liberia in 1981 and the Imports(as % of merchandise exports) of Vanuatu in 1982?
Your response must be concise. 0.74. What is the difference between the Imports(as % of merchandise exports) of Portugal in 1981 and the Imports(as % of merchandise exports) of Vanuatu in 1982?
Make the answer very short. 2.91. What is the difference between the Imports(as % of merchandise exports) in Indonesia in 1981 and the Imports(as % of merchandise exports) in Liberia in 1983?
Provide a succinct answer. 1.25. What is the difference between the Imports(as % of merchandise exports) of Indonesia in 1981 and the Imports(as % of merchandise exports) of Portugal in 1983?
Offer a very short reply. -0.23. What is the difference between the Imports(as % of merchandise exports) of Indonesia in 1981 and the Imports(as % of merchandise exports) of Vanuatu in 1983?
Provide a short and direct response. 2.4. What is the difference between the Imports(as % of merchandise exports) in Liberia in 1981 and the Imports(as % of merchandise exports) in Portugal in 1983?
Your response must be concise. -2.03. What is the difference between the Imports(as % of merchandise exports) of Liberia in 1981 and the Imports(as % of merchandise exports) of Vanuatu in 1983?
Keep it short and to the point. 0.6. What is the difference between the Imports(as % of merchandise exports) of Portugal in 1981 and the Imports(as % of merchandise exports) of Vanuatu in 1983?
Give a very brief answer. 2.77. What is the difference between the Imports(as % of merchandise exports) in Indonesia in 1981 and the Imports(as % of merchandise exports) in Liberia in 1984?
Make the answer very short. 1.67. What is the difference between the Imports(as % of merchandise exports) in Indonesia in 1981 and the Imports(as % of merchandise exports) in Portugal in 1984?
Ensure brevity in your answer.  -0.26. What is the difference between the Imports(as % of merchandise exports) of Indonesia in 1981 and the Imports(as % of merchandise exports) of Vanuatu in 1984?
Your answer should be compact. 2.51. What is the difference between the Imports(as % of merchandise exports) of Liberia in 1981 and the Imports(as % of merchandise exports) of Portugal in 1984?
Provide a short and direct response. -2.06. What is the difference between the Imports(as % of merchandise exports) in Liberia in 1981 and the Imports(as % of merchandise exports) in Vanuatu in 1984?
Keep it short and to the point. 0.71. What is the difference between the Imports(as % of merchandise exports) of Portugal in 1981 and the Imports(as % of merchandise exports) of Vanuatu in 1984?
Offer a terse response. 2.87. What is the difference between the Imports(as % of merchandise exports) in Indonesia in 1982 and the Imports(as % of merchandise exports) in Liberia in 1983?
Your response must be concise. 0.45. What is the difference between the Imports(as % of merchandise exports) in Indonesia in 1982 and the Imports(as % of merchandise exports) in Portugal in 1983?
Your response must be concise. -1.03. What is the difference between the Imports(as % of merchandise exports) of Indonesia in 1982 and the Imports(as % of merchandise exports) of Vanuatu in 1983?
Keep it short and to the point. 1.6. What is the difference between the Imports(as % of merchandise exports) in Liberia in 1982 and the Imports(as % of merchandise exports) in Portugal in 1983?
Give a very brief answer. -2.47. What is the difference between the Imports(as % of merchandise exports) of Liberia in 1982 and the Imports(as % of merchandise exports) of Vanuatu in 1983?
Give a very brief answer. 0.16. What is the difference between the Imports(as % of merchandise exports) in Portugal in 1982 and the Imports(as % of merchandise exports) in Vanuatu in 1983?
Make the answer very short. 2.5. What is the difference between the Imports(as % of merchandise exports) of Indonesia in 1982 and the Imports(as % of merchandise exports) of Liberia in 1984?
Your answer should be compact. 0.87. What is the difference between the Imports(as % of merchandise exports) of Indonesia in 1982 and the Imports(as % of merchandise exports) of Portugal in 1984?
Your answer should be very brief. -1.06. What is the difference between the Imports(as % of merchandise exports) in Indonesia in 1982 and the Imports(as % of merchandise exports) in Vanuatu in 1984?
Your answer should be compact. 1.7. What is the difference between the Imports(as % of merchandise exports) in Liberia in 1982 and the Imports(as % of merchandise exports) in Portugal in 1984?
Keep it short and to the point. -2.5. What is the difference between the Imports(as % of merchandise exports) of Liberia in 1982 and the Imports(as % of merchandise exports) of Vanuatu in 1984?
Your answer should be very brief. 0.26. What is the difference between the Imports(as % of merchandise exports) of Portugal in 1982 and the Imports(as % of merchandise exports) of Vanuatu in 1984?
Give a very brief answer. 2.6. What is the difference between the Imports(as % of merchandise exports) in Indonesia in 1983 and the Imports(as % of merchandise exports) in Liberia in 1984?
Provide a short and direct response. 0.7. What is the difference between the Imports(as % of merchandise exports) in Indonesia in 1983 and the Imports(as % of merchandise exports) in Portugal in 1984?
Your answer should be compact. -1.23. What is the difference between the Imports(as % of merchandise exports) of Indonesia in 1983 and the Imports(as % of merchandise exports) of Vanuatu in 1984?
Your answer should be compact. 1.54. What is the difference between the Imports(as % of merchandise exports) in Liberia in 1983 and the Imports(as % of merchandise exports) in Portugal in 1984?
Provide a succinct answer. -1.51. What is the difference between the Imports(as % of merchandise exports) of Liberia in 1983 and the Imports(as % of merchandise exports) of Vanuatu in 1984?
Make the answer very short. 1.25. What is the difference between the Imports(as % of merchandise exports) of Portugal in 1983 and the Imports(as % of merchandise exports) of Vanuatu in 1984?
Offer a very short reply. 2.74. What is the average Imports(as % of merchandise exports) of Indonesia per year?
Offer a terse response. 2.36. What is the average Imports(as % of merchandise exports) in Liberia per year?
Your answer should be very brief. 1.11. What is the average Imports(as % of merchandise exports) of Portugal per year?
Provide a succinct answer. 3.32. What is the average Imports(as % of merchandise exports) in Vanuatu per year?
Provide a succinct answer. 1.48. In the year 1973, what is the difference between the Imports(as % of merchandise exports) in Indonesia and Imports(as % of merchandise exports) in Liberia?
Make the answer very short. 1.65. In the year 1973, what is the difference between the Imports(as % of merchandise exports) in Indonesia and Imports(as % of merchandise exports) in Portugal?
Your answer should be compact. -0.78. In the year 1973, what is the difference between the Imports(as % of merchandise exports) of Indonesia and Imports(as % of merchandise exports) of Vanuatu?
Offer a very short reply. -1.09. In the year 1973, what is the difference between the Imports(as % of merchandise exports) in Liberia and Imports(as % of merchandise exports) in Portugal?
Offer a terse response. -2.42. In the year 1973, what is the difference between the Imports(as % of merchandise exports) in Liberia and Imports(as % of merchandise exports) in Vanuatu?
Your response must be concise. -2.74. In the year 1973, what is the difference between the Imports(as % of merchandise exports) in Portugal and Imports(as % of merchandise exports) in Vanuatu?
Provide a succinct answer. -0.32. In the year 1974, what is the difference between the Imports(as % of merchandise exports) in Indonesia and Imports(as % of merchandise exports) in Liberia?
Your answer should be very brief. 1.57. In the year 1974, what is the difference between the Imports(as % of merchandise exports) in Indonesia and Imports(as % of merchandise exports) in Portugal?
Provide a succinct answer. -1.34. In the year 1974, what is the difference between the Imports(as % of merchandise exports) of Indonesia and Imports(as % of merchandise exports) of Vanuatu?
Offer a terse response. -1.29. In the year 1974, what is the difference between the Imports(as % of merchandise exports) in Liberia and Imports(as % of merchandise exports) in Portugal?
Keep it short and to the point. -2.91. In the year 1974, what is the difference between the Imports(as % of merchandise exports) of Liberia and Imports(as % of merchandise exports) of Vanuatu?
Make the answer very short. -2.86. In the year 1974, what is the difference between the Imports(as % of merchandise exports) of Portugal and Imports(as % of merchandise exports) of Vanuatu?
Your response must be concise. 0.05. In the year 1975, what is the difference between the Imports(as % of merchandise exports) of Indonesia and Imports(as % of merchandise exports) of Liberia?
Give a very brief answer. 0.81. In the year 1975, what is the difference between the Imports(as % of merchandise exports) of Indonesia and Imports(as % of merchandise exports) of Portugal?
Your response must be concise. -0.96. In the year 1975, what is the difference between the Imports(as % of merchandise exports) of Indonesia and Imports(as % of merchandise exports) of Vanuatu?
Make the answer very short. -0.14. In the year 1975, what is the difference between the Imports(as % of merchandise exports) of Liberia and Imports(as % of merchandise exports) of Portugal?
Provide a succinct answer. -1.77. In the year 1975, what is the difference between the Imports(as % of merchandise exports) in Liberia and Imports(as % of merchandise exports) in Vanuatu?
Give a very brief answer. -0.95. In the year 1975, what is the difference between the Imports(as % of merchandise exports) of Portugal and Imports(as % of merchandise exports) of Vanuatu?
Give a very brief answer. 0.83. In the year 1980, what is the difference between the Imports(as % of merchandise exports) in Indonesia and Imports(as % of merchandise exports) in Liberia?
Offer a terse response. 1.25. In the year 1980, what is the difference between the Imports(as % of merchandise exports) of Indonesia and Imports(as % of merchandise exports) of Portugal?
Keep it short and to the point. -1.43. In the year 1980, what is the difference between the Imports(as % of merchandise exports) of Indonesia and Imports(as % of merchandise exports) of Vanuatu?
Provide a short and direct response. 1.92. In the year 1980, what is the difference between the Imports(as % of merchandise exports) in Liberia and Imports(as % of merchandise exports) in Portugal?
Make the answer very short. -2.67. In the year 1980, what is the difference between the Imports(as % of merchandise exports) of Liberia and Imports(as % of merchandise exports) of Vanuatu?
Your answer should be very brief. 0.67. In the year 1980, what is the difference between the Imports(as % of merchandise exports) in Portugal and Imports(as % of merchandise exports) in Vanuatu?
Offer a very short reply. 3.34. In the year 1981, what is the difference between the Imports(as % of merchandise exports) of Indonesia and Imports(as % of merchandise exports) of Liberia?
Your answer should be compact. 1.8. In the year 1981, what is the difference between the Imports(as % of merchandise exports) of Indonesia and Imports(as % of merchandise exports) of Portugal?
Your response must be concise. -0.36. In the year 1981, what is the difference between the Imports(as % of merchandise exports) of Indonesia and Imports(as % of merchandise exports) of Vanuatu?
Offer a terse response. 2.46. In the year 1981, what is the difference between the Imports(as % of merchandise exports) of Liberia and Imports(as % of merchandise exports) of Portugal?
Your answer should be very brief. -2.16. In the year 1981, what is the difference between the Imports(as % of merchandise exports) in Liberia and Imports(as % of merchandise exports) in Vanuatu?
Offer a very short reply. 0.66. In the year 1981, what is the difference between the Imports(as % of merchandise exports) of Portugal and Imports(as % of merchandise exports) of Vanuatu?
Provide a succinct answer. 2.82. In the year 1982, what is the difference between the Imports(as % of merchandise exports) of Indonesia and Imports(as % of merchandise exports) of Liberia?
Offer a very short reply. 1.44. In the year 1982, what is the difference between the Imports(as % of merchandise exports) of Indonesia and Imports(as % of merchandise exports) of Portugal?
Offer a very short reply. -0.9. In the year 1982, what is the difference between the Imports(as % of merchandise exports) in Indonesia and Imports(as % of merchandise exports) in Vanuatu?
Your response must be concise. 1.74. In the year 1982, what is the difference between the Imports(as % of merchandise exports) of Liberia and Imports(as % of merchandise exports) of Portugal?
Ensure brevity in your answer.  -2.34. In the year 1982, what is the difference between the Imports(as % of merchandise exports) of Liberia and Imports(as % of merchandise exports) of Vanuatu?
Make the answer very short. 0.3. In the year 1982, what is the difference between the Imports(as % of merchandise exports) of Portugal and Imports(as % of merchandise exports) of Vanuatu?
Your response must be concise. 2.64. In the year 1983, what is the difference between the Imports(as % of merchandise exports) in Indonesia and Imports(as % of merchandise exports) in Liberia?
Provide a short and direct response. 0.28. In the year 1983, what is the difference between the Imports(as % of merchandise exports) of Indonesia and Imports(as % of merchandise exports) of Portugal?
Your answer should be very brief. -1.2. In the year 1983, what is the difference between the Imports(as % of merchandise exports) in Indonesia and Imports(as % of merchandise exports) in Vanuatu?
Your answer should be compact. 1.43. In the year 1983, what is the difference between the Imports(as % of merchandise exports) of Liberia and Imports(as % of merchandise exports) of Portugal?
Provide a succinct answer. -1.48. In the year 1983, what is the difference between the Imports(as % of merchandise exports) of Liberia and Imports(as % of merchandise exports) of Vanuatu?
Your answer should be very brief. 1.15. In the year 1983, what is the difference between the Imports(as % of merchandise exports) in Portugal and Imports(as % of merchandise exports) in Vanuatu?
Provide a short and direct response. 2.63. In the year 1984, what is the difference between the Imports(as % of merchandise exports) of Indonesia and Imports(as % of merchandise exports) of Liberia?
Offer a terse response. 1.21. In the year 1984, what is the difference between the Imports(as % of merchandise exports) of Indonesia and Imports(as % of merchandise exports) of Portugal?
Your answer should be compact. -0.72. In the year 1984, what is the difference between the Imports(as % of merchandise exports) of Indonesia and Imports(as % of merchandise exports) of Vanuatu?
Offer a terse response. 2.05. In the year 1984, what is the difference between the Imports(as % of merchandise exports) of Liberia and Imports(as % of merchandise exports) of Portugal?
Ensure brevity in your answer.  -1.93. In the year 1984, what is the difference between the Imports(as % of merchandise exports) of Liberia and Imports(as % of merchandise exports) of Vanuatu?
Provide a short and direct response. 0.83. In the year 1984, what is the difference between the Imports(as % of merchandise exports) of Portugal and Imports(as % of merchandise exports) of Vanuatu?
Your answer should be compact. 2.77. What is the ratio of the Imports(as % of merchandise exports) of Indonesia in 1973 to that in 1974?
Keep it short and to the point. 1.02. What is the ratio of the Imports(as % of merchandise exports) of Liberia in 1973 to that in 1974?
Make the answer very short. 0.95. What is the ratio of the Imports(as % of merchandise exports) in Portugal in 1973 to that in 1974?
Offer a terse response. 0.86. What is the ratio of the Imports(as % of merchandise exports) of Vanuatu in 1973 to that in 1974?
Provide a succinct answer. 0.96. What is the ratio of the Imports(as % of merchandise exports) in Indonesia in 1973 to that in 1975?
Your answer should be compact. 1.24. What is the ratio of the Imports(as % of merchandise exports) of Liberia in 1973 to that in 1975?
Give a very brief answer. 0.67. What is the ratio of the Imports(as % of merchandise exports) of Portugal in 1973 to that in 1975?
Your response must be concise. 1.1. What is the ratio of the Imports(as % of merchandise exports) in Vanuatu in 1973 to that in 1975?
Provide a short and direct response. 1.68. What is the ratio of the Imports(as % of merchandise exports) in Indonesia in 1973 to that in 1980?
Offer a terse response. 0.99. What is the ratio of the Imports(as % of merchandise exports) of Liberia in 1973 to that in 1980?
Provide a succinct answer. 0.64. What is the ratio of the Imports(as % of merchandise exports) in Portugal in 1973 to that in 1980?
Provide a short and direct response. 0.82. What is the ratio of the Imports(as % of merchandise exports) of Vanuatu in 1973 to that in 1980?
Your response must be concise. 6.72. What is the ratio of the Imports(as % of merchandise exports) in Indonesia in 1973 to that in 1981?
Your answer should be compact. 0.8. What is the ratio of the Imports(as % of merchandise exports) in Liberia in 1973 to that in 1981?
Your answer should be very brief. 0.64. What is the ratio of the Imports(as % of merchandise exports) in Portugal in 1973 to that in 1981?
Ensure brevity in your answer.  0.95. What is the ratio of the Imports(as % of merchandise exports) in Vanuatu in 1973 to that in 1981?
Your answer should be compact. 6.48. What is the ratio of the Imports(as % of merchandise exports) of Indonesia in 1973 to that in 1982?
Your answer should be compact. 1.1. What is the ratio of the Imports(as % of merchandise exports) of Liberia in 1973 to that in 1982?
Provide a short and direct response. 1.01. What is the ratio of the Imports(as % of merchandise exports) in Portugal in 1973 to that in 1982?
Offer a terse response. 1.03. What is the ratio of the Imports(as % of merchandise exports) in Vanuatu in 1973 to that in 1982?
Offer a very short reply. 7.74. What is the ratio of the Imports(as % of merchandise exports) in Indonesia in 1973 to that in 1983?
Keep it short and to the point. 1.19. What is the ratio of the Imports(as % of merchandise exports) of Liberia in 1973 to that in 1983?
Your response must be concise. 0.44. What is the ratio of the Imports(as % of merchandise exports) of Portugal in 1973 to that in 1983?
Your answer should be very brief. 0.99. What is the ratio of the Imports(as % of merchandise exports) in Vanuatu in 1973 to that in 1983?
Your answer should be very brief. 5.89. What is the ratio of the Imports(as % of merchandise exports) of Indonesia in 1973 to that in 1984?
Provide a short and direct response. 0.95. What is the ratio of the Imports(as % of merchandise exports) of Liberia in 1973 to that in 1984?
Ensure brevity in your answer.  0.58. What is the ratio of the Imports(as % of merchandise exports) in Portugal in 1973 to that in 1984?
Ensure brevity in your answer.  0.98. What is the ratio of the Imports(as % of merchandise exports) in Vanuatu in 1973 to that in 1984?
Provide a short and direct response. 7.16. What is the ratio of the Imports(as % of merchandise exports) in Indonesia in 1974 to that in 1975?
Offer a very short reply. 1.22. What is the ratio of the Imports(as % of merchandise exports) in Liberia in 1974 to that in 1975?
Offer a very short reply. 0.7. What is the ratio of the Imports(as % of merchandise exports) in Portugal in 1974 to that in 1975?
Make the answer very short. 1.27. What is the ratio of the Imports(as % of merchandise exports) of Vanuatu in 1974 to that in 1975?
Your answer should be very brief. 1.76. What is the ratio of the Imports(as % of merchandise exports) of Indonesia in 1974 to that in 1980?
Offer a very short reply. 0.97. What is the ratio of the Imports(as % of merchandise exports) of Liberia in 1974 to that in 1980?
Make the answer very short. 0.67. What is the ratio of the Imports(as % of merchandise exports) of Portugal in 1974 to that in 1980?
Make the answer very short. 0.96. What is the ratio of the Imports(as % of merchandise exports) of Vanuatu in 1974 to that in 1980?
Give a very brief answer. 7.01. What is the ratio of the Imports(as % of merchandise exports) of Indonesia in 1974 to that in 1981?
Give a very brief answer. 0.79. What is the ratio of the Imports(as % of merchandise exports) of Liberia in 1974 to that in 1981?
Ensure brevity in your answer.  0.67. What is the ratio of the Imports(as % of merchandise exports) of Portugal in 1974 to that in 1981?
Your response must be concise. 1.1. What is the ratio of the Imports(as % of merchandise exports) of Vanuatu in 1974 to that in 1981?
Your response must be concise. 6.76. What is the ratio of the Imports(as % of merchandise exports) of Indonesia in 1974 to that in 1982?
Your answer should be very brief. 1.08. What is the ratio of the Imports(as % of merchandise exports) in Liberia in 1974 to that in 1982?
Ensure brevity in your answer.  1.06. What is the ratio of the Imports(as % of merchandise exports) in Portugal in 1974 to that in 1982?
Offer a terse response. 1.2. What is the ratio of the Imports(as % of merchandise exports) in Vanuatu in 1974 to that in 1982?
Your answer should be very brief. 8.07. What is the ratio of the Imports(as % of merchandise exports) of Indonesia in 1974 to that in 1983?
Provide a short and direct response. 1.17. What is the ratio of the Imports(as % of merchandise exports) in Liberia in 1974 to that in 1983?
Provide a short and direct response. 0.46. What is the ratio of the Imports(as % of merchandise exports) of Portugal in 1974 to that in 1983?
Ensure brevity in your answer.  1.15. What is the ratio of the Imports(as % of merchandise exports) of Vanuatu in 1974 to that in 1983?
Your answer should be very brief. 6.14. What is the ratio of the Imports(as % of merchandise exports) of Indonesia in 1974 to that in 1984?
Offer a very short reply. 0.93. What is the ratio of the Imports(as % of merchandise exports) of Liberia in 1974 to that in 1984?
Your answer should be very brief. 0.6. What is the ratio of the Imports(as % of merchandise exports) in Portugal in 1974 to that in 1984?
Offer a terse response. 1.14. What is the ratio of the Imports(as % of merchandise exports) in Vanuatu in 1974 to that in 1984?
Ensure brevity in your answer.  7.47. What is the ratio of the Imports(as % of merchandise exports) in Indonesia in 1975 to that in 1980?
Give a very brief answer. 0.8. What is the ratio of the Imports(as % of merchandise exports) of Liberia in 1975 to that in 1980?
Offer a terse response. 0.95. What is the ratio of the Imports(as % of merchandise exports) in Portugal in 1975 to that in 1980?
Give a very brief answer. 0.75. What is the ratio of the Imports(as % of merchandise exports) in Vanuatu in 1975 to that in 1980?
Your response must be concise. 3.99. What is the ratio of the Imports(as % of merchandise exports) of Indonesia in 1975 to that in 1981?
Offer a terse response. 0.65. What is the ratio of the Imports(as % of merchandise exports) of Liberia in 1975 to that in 1981?
Keep it short and to the point. 0.95. What is the ratio of the Imports(as % of merchandise exports) in Portugal in 1975 to that in 1981?
Your answer should be compact. 0.86. What is the ratio of the Imports(as % of merchandise exports) of Vanuatu in 1975 to that in 1981?
Ensure brevity in your answer.  3.85. What is the ratio of the Imports(as % of merchandise exports) of Indonesia in 1975 to that in 1982?
Keep it short and to the point. 0.89. What is the ratio of the Imports(as % of merchandise exports) of Liberia in 1975 to that in 1982?
Ensure brevity in your answer.  1.51. What is the ratio of the Imports(as % of merchandise exports) in Portugal in 1975 to that in 1982?
Give a very brief answer. 0.94. What is the ratio of the Imports(as % of merchandise exports) in Vanuatu in 1975 to that in 1982?
Your answer should be compact. 4.6. What is the ratio of the Imports(as % of merchandise exports) in Indonesia in 1975 to that in 1983?
Provide a succinct answer. 0.96. What is the ratio of the Imports(as % of merchandise exports) of Liberia in 1975 to that in 1983?
Provide a short and direct response. 0.65. What is the ratio of the Imports(as % of merchandise exports) of Portugal in 1975 to that in 1983?
Your response must be concise. 0.9. What is the ratio of the Imports(as % of merchandise exports) in Vanuatu in 1975 to that in 1983?
Your answer should be very brief. 3.5. What is the ratio of the Imports(as % of merchandise exports) in Indonesia in 1975 to that in 1984?
Your answer should be very brief. 0.77. What is the ratio of the Imports(as % of merchandise exports) of Liberia in 1975 to that in 1984?
Give a very brief answer. 0.86. What is the ratio of the Imports(as % of merchandise exports) of Portugal in 1975 to that in 1984?
Provide a short and direct response. 0.89. What is the ratio of the Imports(as % of merchandise exports) of Vanuatu in 1975 to that in 1984?
Offer a very short reply. 4.25. What is the ratio of the Imports(as % of merchandise exports) in Indonesia in 1980 to that in 1981?
Ensure brevity in your answer.  0.81. What is the ratio of the Imports(as % of merchandise exports) of Liberia in 1980 to that in 1981?
Keep it short and to the point. 0.99. What is the ratio of the Imports(as % of merchandise exports) in Portugal in 1980 to that in 1981?
Your answer should be very brief. 1.15. What is the ratio of the Imports(as % of merchandise exports) in Vanuatu in 1980 to that in 1981?
Make the answer very short. 0.96. What is the ratio of the Imports(as % of merchandise exports) in Indonesia in 1980 to that in 1982?
Provide a short and direct response. 1.11. What is the ratio of the Imports(as % of merchandise exports) of Liberia in 1980 to that in 1982?
Offer a very short reply. 1.58. What is the ratio of the Imports(as % of merchandise exports) of Portugal in 1980 to that in 1982?
Your answer should be compact. 1.25. What is the ratio of the Imports(as % of merchandise exports) in Vanuatu in 1980 to that in 1982?
Provide a succinct answer. 1.15. What is the ratio of the Imports(as % of merchandise exports) of Indonesia in 1980 to that in 1983?
Provide a succinct answer. 1.2. What is the ratio of the Imports(as % of merchandise exports) in Liberia in 1980 to that in 1983?
Provide a succinct answer. 0.68. What is the ratio of the Imports(as % of merchandise exports) of Portugal in 1980 to that in 1983?
Provide a succinct answer. 1.2. What is the ratio of the Imports(as % of merchandise exports) of Vanuatu in 1980 to that in 1983?
Offer a terse response. 0.88. What is the ratio of the Imports(as % of merchandise exports) of Indonesia in 1980 to that in 1984?
Your answer should be very brief. 0.96. What is the ratio of the Imports(as % of merchandise exports) in Liberia in 1980 to that in 1984?
Ensure brevity in your answer.  0.9. What is the ratio of the Imports(as % of merchandise exports) of Portugal in 1980 to that in 1984?
Your response must be concise. 1.19. What is the ratio of the Imports(as % of merchandise exports) in Vanuatu in 1980 to that in 1984?
Provide a short and direct response. 1.07. What is the ratio of the Imports(as % of merchandise exports) of Indonesia in 1981 to that in 1982?
Your answer should be compact. 1.37. What is the ratio of the Imports(as % of merchandise exports) in Liberia in 1981 to that in 1982?
Offer a very short reply. 1.59. What is the ratio of the Imports(as % of merchandise exports) of Portugal in 1981 to that in 1982?
Provide a succinct answer. 1.09. What is the ratio of the Imports(as % of merchandise exports) of Vanuatu in 1981 to that in 1982?
Offer a terse response. 1.19. What is the ratio of the Imports(as % of merchandise exports) of Indonesia in 1981 to that in 1983?
Offer a very short reply. 1.48. What is the ratio of the Imports(as % of merchandise exports) in Liberia in 1981 to that in 1983?
Provide a succinct answer. 0.69. What is the ratio of the Imports(as % of merchandise exports) in Portugal in 1981 to that in 1983?
Your answer should be compact. 1.04. What is the ratio of the Imports(as % of merchandise exports) in Vanuatu in 1981 to that in 1983?
Offer a very short reply. 0.91. What is the ratio of the Imports(as % of merchandise exports) in Indonesia in 1981 to that in 1984?
Make the answer very short. 1.18. What is the ratio of the Imports(as % of merchandise exports) of Liberia in 1981 to that in 1984?
Your answer should be very brief. 0.9. What is the ratio of the Imports(as % of merchandise exports) of Portugal in 1981 to that in 1984?
Provide a short and direct response. 1.03. What is the ratio of the Imports(as % of merchandise exports) of Vanuatu in 1981 to that in 1984?
Your answer should be compact. 1.1. What is the ratio of the Imports(as % of merchandise exports) in Indonesia in 1982 to that in 1983?
Offer a terse response. 1.08. What is the ratio of the Imports(as % of merchandise exports) in Liberia in 1982 to that in 1983?
Keep it short and to the point. 0.43. What is the ratio of the Imports(as % of merchandise exports) in Portugal in 1982 to that in 1983?
Offer a terse response. 0.96. What is the ratio of the Imports(as % of merchandise exports) of Vanuatu in 1982 to that in 1983?
Provide a succinct answer. 0.76. What is the ratio of the Imports(as % of merchandise exports) of Indonesia in 1982 to that in 1984?
Offer a terse response. 0.86. What is the ratio of the Imports(as % of merchandise exports) in Liberia in 1982 to that in 1984?
Your response must be concise. 0.57. What is the ratio of the Imports(as % of merchandise exports) of Portugal in 1982 to that in 1984?
Provide a short and direct response. 0.95. What is the ratio of the Imports(as % of merchandise exports) of Vanuatu in 1982 to that in 1984?
Offer a terse response. 0.92. What is the ratio of the Imports(as % of merchandise exports) in Indonesia in 1983 to that in 1984?
Ensure brevity in your answer.  0.8. What is the ratio of the Imports(as % of merchandise exports) in Liberia in 1983 to that in 1984?
Your response must be concise. 1.32. What is the ratio of the Imports(as % of merchandise exports) in Vanuatu in 1983 to that in 1984?
Keep it short and to the point. 1.22. What is the difference between the highest and the second highest Imports(as % of merchandise exports) of Indonesia?
Your answer should be compact. 0.46. What is the difference between the highest and the second highest Imports(as % of merchandise exports) of Liberia?
Keep it short and to the point. 0.42. What is the difference between the highest and the second highest Imports(as % of merchandise exports) of Portugal?
Keep it short and to the point. 0.16. What is the difference between the highest and the second highest Imports(as % of merchandise exports) in Vanuatu?
Ensure brevity in your answer.  0.15. What is the difference between the highest and the lowest Imports(as % of merchandise exports) in Indonesia?
Your response must be concise. 1.05. What is the difference between the highest and the lowest Imports(as % of merchandise exports) of Liberia?
Keep it short and to the point. 0.99. What is the difference between the highest and the lowest Imports(as % of merchandise exports) in Portugal?
Provide a succinct answer. 0.96. What is the difference between the highest and the lowest Imports(as % of merchandise exports) in Vanuatu?
Keep it short and to the point. 3.2. 